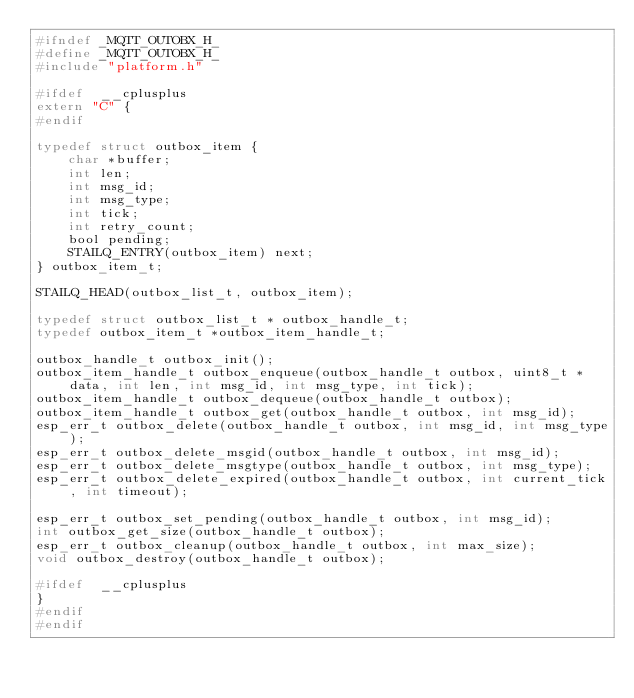<code> <loc_0><loc_0><loc_500><loc_500><_C_>#ifndef _MQTT_OUTOBX_H_
#define _MQTT_OUTOBX_H_
#include "platform.h"

#ifdef  __cplusplus
extern "C" {
#endif

typedef struct outbox_item {
    char *buffer;
    int len;
    int msg_id;
    int msg_type;
    int tick;
    int retry_count;
    bool pending;
    STAILQ_ENTRY(outbox_item) next;
} outbox_item_t;

STAILQ_HEAD(outbox_list_t, outbox_item);

typedef struct outbox_list_t * outbox_handle_t;
typedef outbox_item_t *outbox_item_handle_t;

outbox_handle_t outbox_init();
outbox_item_handle_t outbox_enqueue(outbox_handle_t outbox, uint8_t *data, int len, int msg_id, int msg_type, int tick);
outbox_item_handle_t outbox_dequeue(outbox_handle_t outbox);
outbox_item_handle_t outbox_get(outbox_handle_t outbox, int msg_id);
esp_err_t outbox_delete(outbox_handle_t outbox, int msg_id, int msg_type);
esp_err_t outbox_delete_msgid(outbox_handle_t outbox, int msg_id);
esp_err_t outbox_delete_msgtype(outbox_handle_t outbox, int msg_type);
esp_err_t outbox_delete_expired(outbox_handle_t outbox, int current_tick, int timeout);

esp_err_t outbox_set_pending(outbox_handle_t outbox, int msg_id);
int outbox_get_size(outbox_handle_t outbox);
esp_err_t outbox_cleanup(outbox_handle_t outbox, int max_size);
void outbox_destroy(outbox_handle_t outbox);

#ifdef  __cplusplus
}
#endif
#endif
</code> 